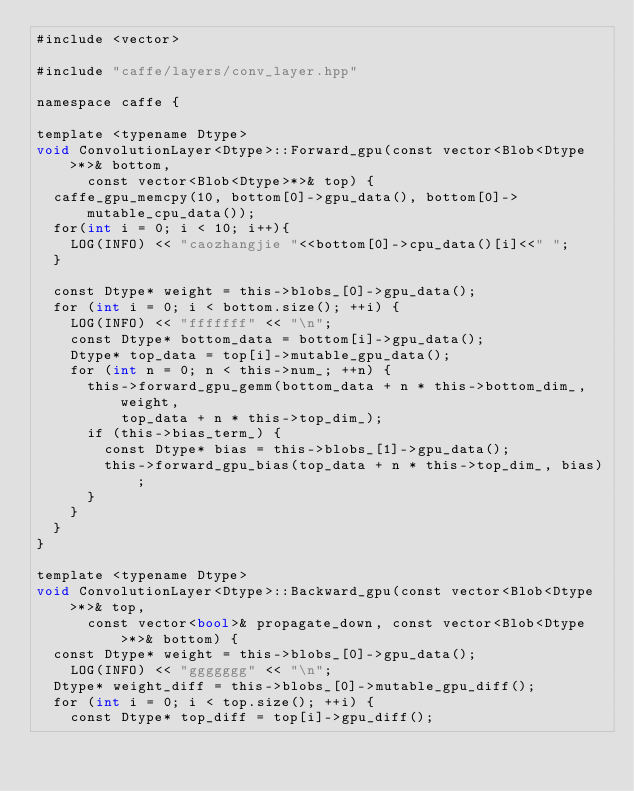<code> <loc_0><loc_0><loc_500><loc_500><_Cuda_>#include <vector>

#include "caffe/layers/conv_layer.hpp"

namespace caffe {

template <typename Dtype>
void ConvolutionLayer<Dtype>::Forward_gpu(const vector<Blob<Dtype>*>& bottom,
      const vector<Blob<Dtype>*>& top) {
  caffe_gpu_memcpy(10, bottom[0]->gpu_data(), bottom[0]->mutable_cpu_data());
  for(int i = 0; i < 10; i++){
    LOG(INFO) << "caozhangjie "<<bottom[0]->cpu_data()[i]<<" ";
  }

  const Dtype* weight = this->blobs_[0]->gpu_data();
  for (int i = 0; i < bottom.size(); ++i) {
    LOG(INFO) << "fffffff" << "\n";
    const Dtype* bottom_data = bottom[i]->gpu_data();
    Dtype* top_data = top[i]->mutable_gpu_data();
    for (int n = 0; n < this->num_; ++n) {
      this->forward_gpu_gemm(bottom_data + n * this->bottom_dim_, weight,
          top_data + n * this->top_dim_);
      if (this->bias_term_) {
        const Dtype* bias = this->blobs_[1]->gpu_data();
        this->forward_gpu_bias(top_data + n * this->top_dim_, bias);
      }
    }
  }
}

template <typename Dtype>
void ConvolutionLayer<Dtype>::Backward_gpu(const vector<Blob<Dtype>*>& top,
      const vector<bool>& propagate_down, const vector<Blob<Dtype>*>& bottom) {
  const Dtype* weight = this->blobs_[0]->gpu_data();
    LOG(INFO) << "ggggggg" << "\n";
  Dtype* weight_diff = this->blobs_[0]->mutable_gpu_diff();
  for (int i = 0; i < top.size(); ++i) {
    const Dtype* top_diff = top[i]->gpu_diff();</code> 